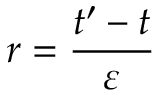Convert formula to latex. <formula><loc_0><loc_0><loc_500><loc_500>r = \frac { t ^ { \prime } - t } { \varepsilon }</formula> 